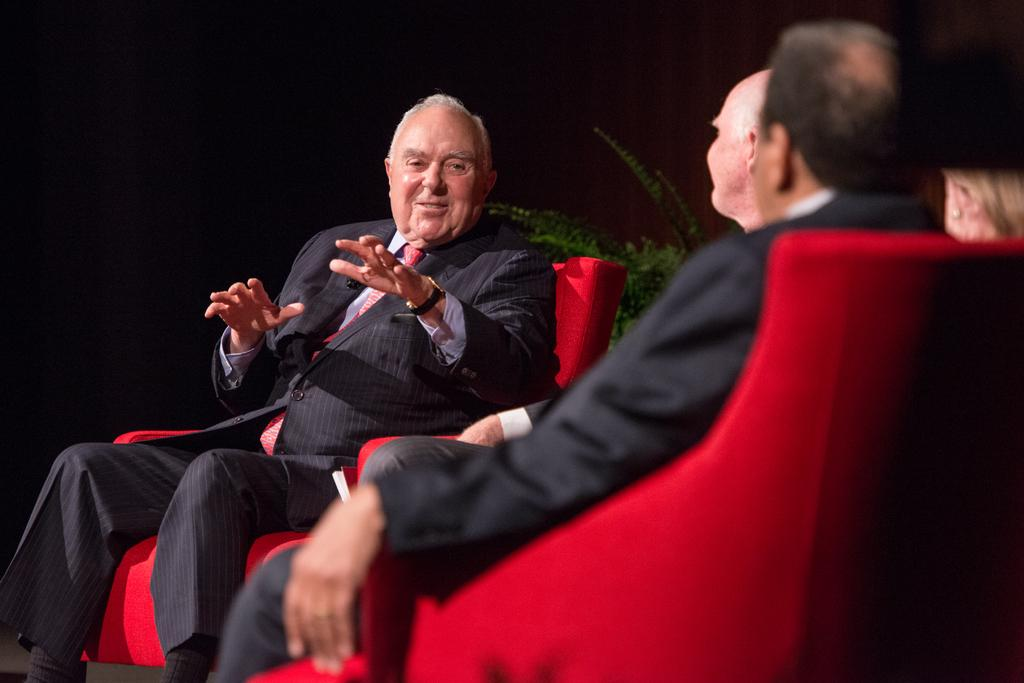What are the people in the image doing? The persons in the image are sitting on chairs. What color are the chairs? The chairs are red in color. Can you describe the person sitting on a chair in the image? A person wearing a suit and tie is sitting on a chair. What is located behind the person in the suit and tie? There is a plant behind the person in the suit and tie. What is the color of the background of the background in the image? The background of the image is black. What type of test is being conducted in the image? There is no test being conducted in the image; it shows people sitting on red chairs. What invention is being demonstrated in the image? There is no invention being demonstrated in the image; it shows people sitting on red chairs. 